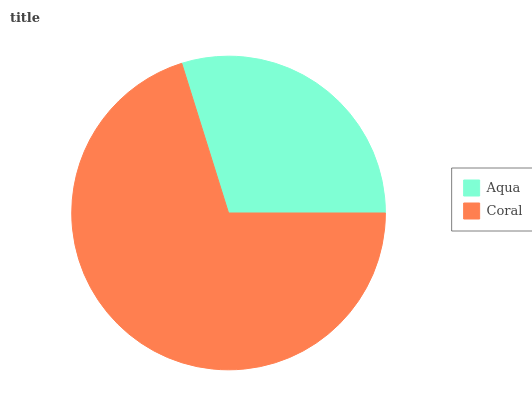Is Aqua the minimum?
Answer yes or no. Yes. Is Coral the maximum?
Answer yes or no. Yes. Is Coral the minimum?
Answer yes or no. No. Is Coral greater than Aqua?
Answer yes or no. Yes. Is Aqua less than Coral?
Answer yes or no. Yes. Is Aqua greater than Coral?
Answer yes or no. No. Is Coral less than Aqua?
Answer yes or no. No. Is Coral the high median?
Answer yes or no. Yes. Is Aqua the low median?
Answer yes or no. Yes. Is Aqua the high median?
Answer yes or no. No. Is Coral the low median?
Answer yes or no. No. 